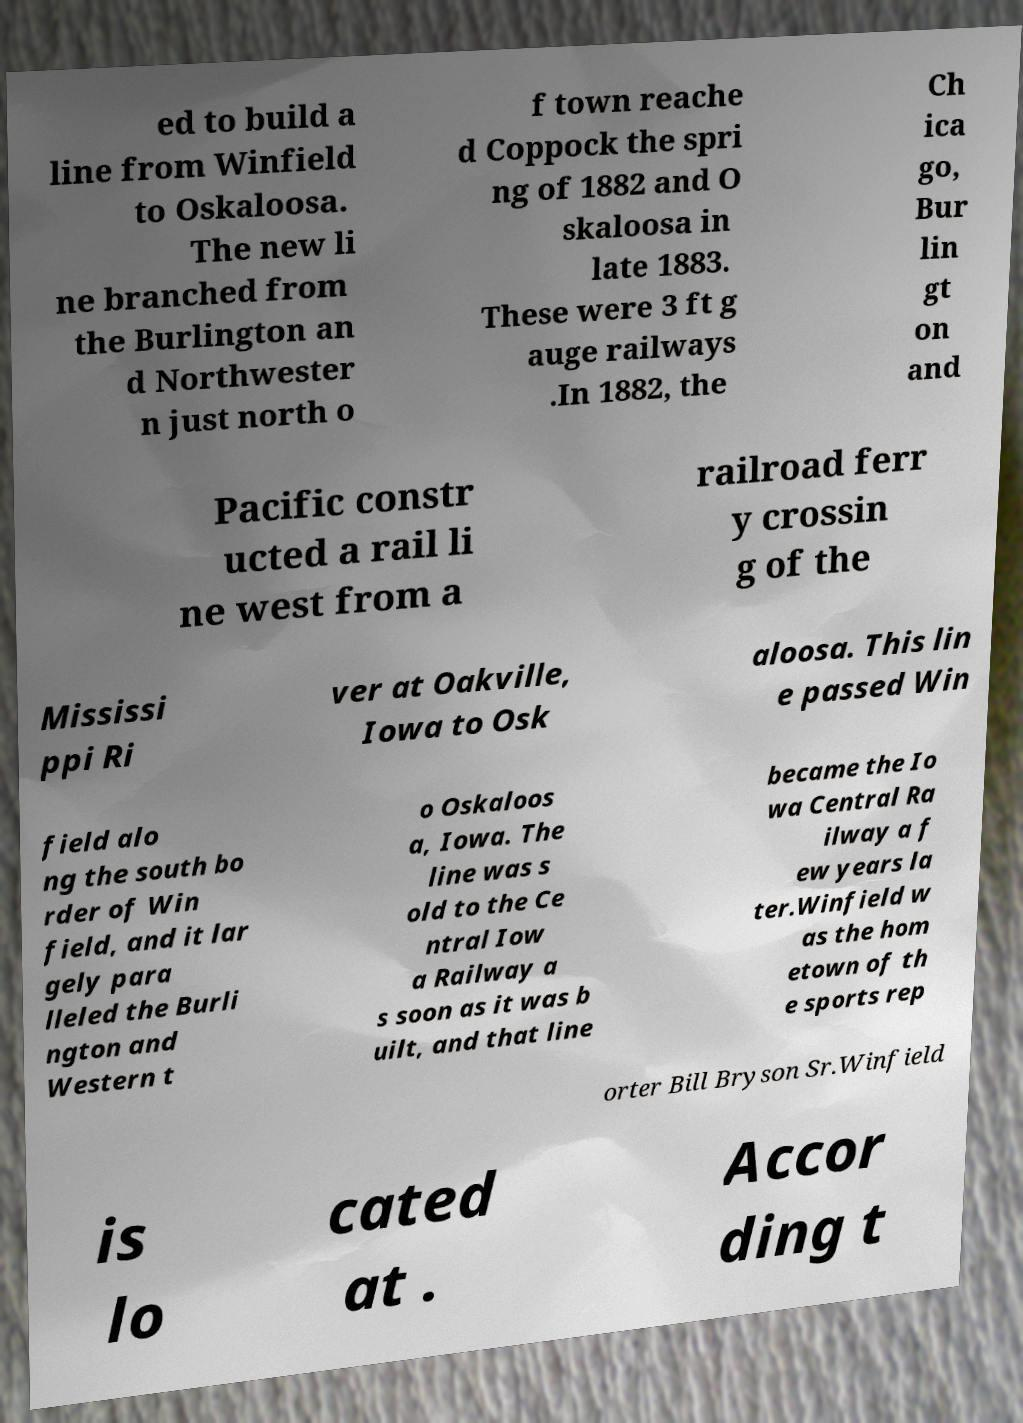Please read and relay the text visible in this image. What does it say? ed to build a line from Winfield to Oskaloosa. The new li ne branched from the Burlington an d Northwester n just north o f town reache d Coppock the spri ng of 1882 and O skaloosa in late 1883. These were 3 ft g auge railways .In 1882, the Ch ica go, Bur lin gt on and Pacific constr ucted a rail li ne west from a railroad ferr y crossin g of the Mississi ppi Ri ver at Oakville, Iowa to Osk aloosa. This lin e passed Win field alo ng the south bo rder of Win field, and it lar gely para lleled the Burli ngton and Western t o Oskaloos a, Iowa. The line was s old to the Ce ntral Iow a Railway a s soon as it was b uilt, and that line became the Io wa Central Ra ilway a f ew years la ter.Winfield w as the hom etown of th e sports rep orter Bill Bryson Sr.Winfield is lo cated at . Accor ding t 